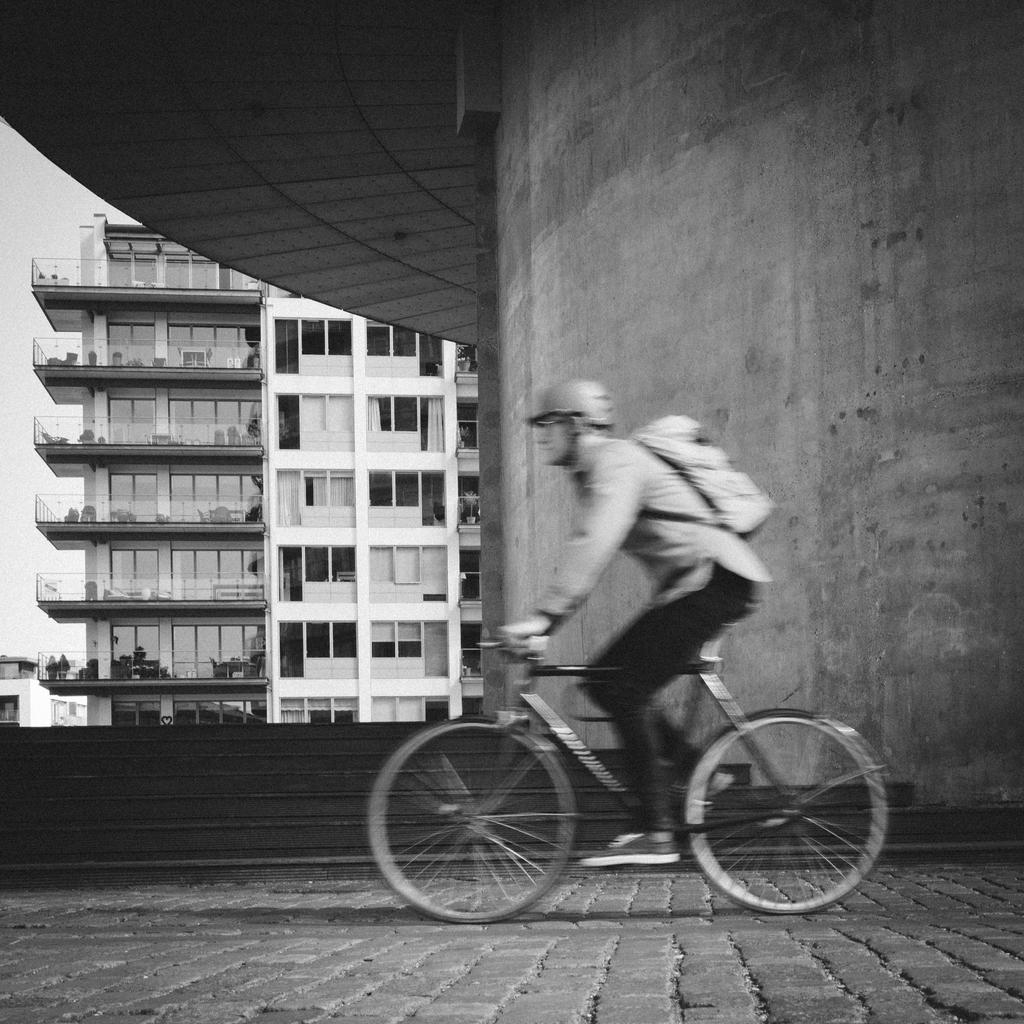What is the main subject of the image? There is a person riding a bicycle in the image. What can be seen in the background of the image? There is a building and the sky visible in the background of the image. What type of popcorn is the person eating while riding the bicycle in the image? There is no popcorn present in the image; the person is riding a bicycle without any food. 